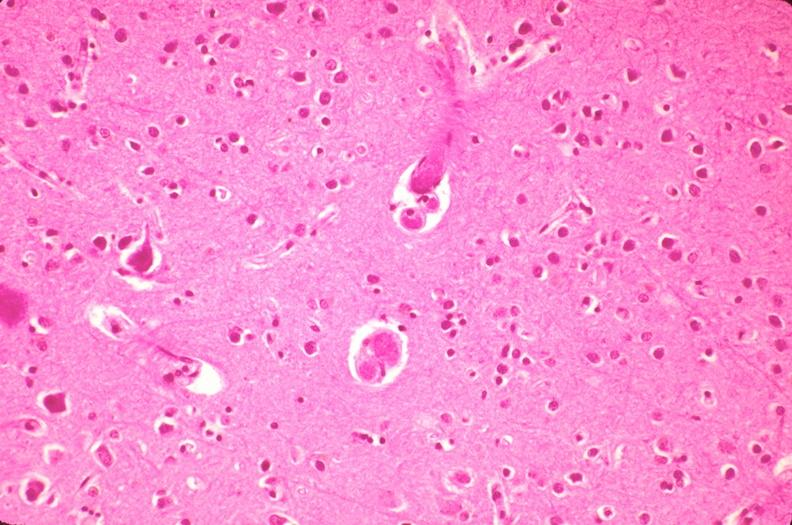s cranial artery present?
Answer the question using a single word or phrase. No 